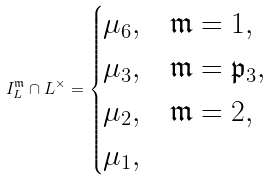Convert formula to latex. <formula><loc_0><loc_0><loc_500><loc_500>I _ { L } ^ { \mathfrak { m } } \cap L ^ { \times } = \begin{cases} \mu _ { 6 } , & \mathfrak { m } = 1 , \\ \mu _ { 3 } , & \mathfrak { m } = \mathfrak { p } _ { 3 } , \\ \mu _ { 2 } , & \mathfrak { m } = 2 , \\ \mu _ { 1 } , & \end{cases}</formula> 